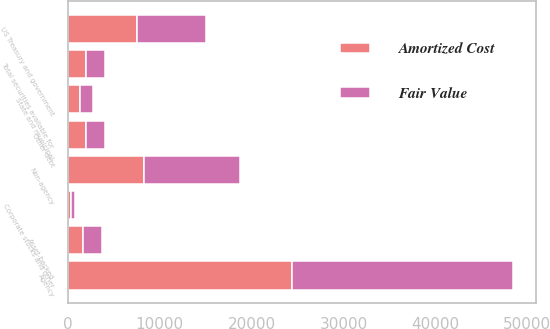Convert chart. <chart><loc_0><loc_0><loc_500><loc_500><stacked_bar_chart><ecel><fcel>US Treasury and government<fcel>Agency<fcel>Non-agency<fcel>Asset-backed<fcel>State and municipal<fcel>Other debt<fcel>Corporate stocks and other<fcel>Total securities available for<nl><fcel>Fair Value<fcel>7548<fcel>24076<fcel>10419<fcel>2019<fcel>1346<fcel>1984<fcel>360<fcel>2017<nl><fcel>Amortized Cost<fcel>7520<fcel>24438<fcel>8302<fcel>1668<fcel>1350<fcel>2015<fcel>360<fcel>2017<nl></chart> 